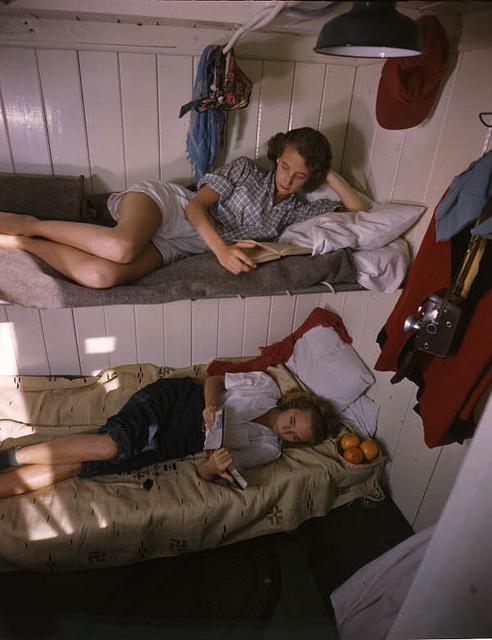Are they on a bunk bed?
Give a very brief answer. Yes. How many people are in this picture?
Answer briefly. 2. What is the upper "bed" usually called?
Be succinct. Top bunk. 